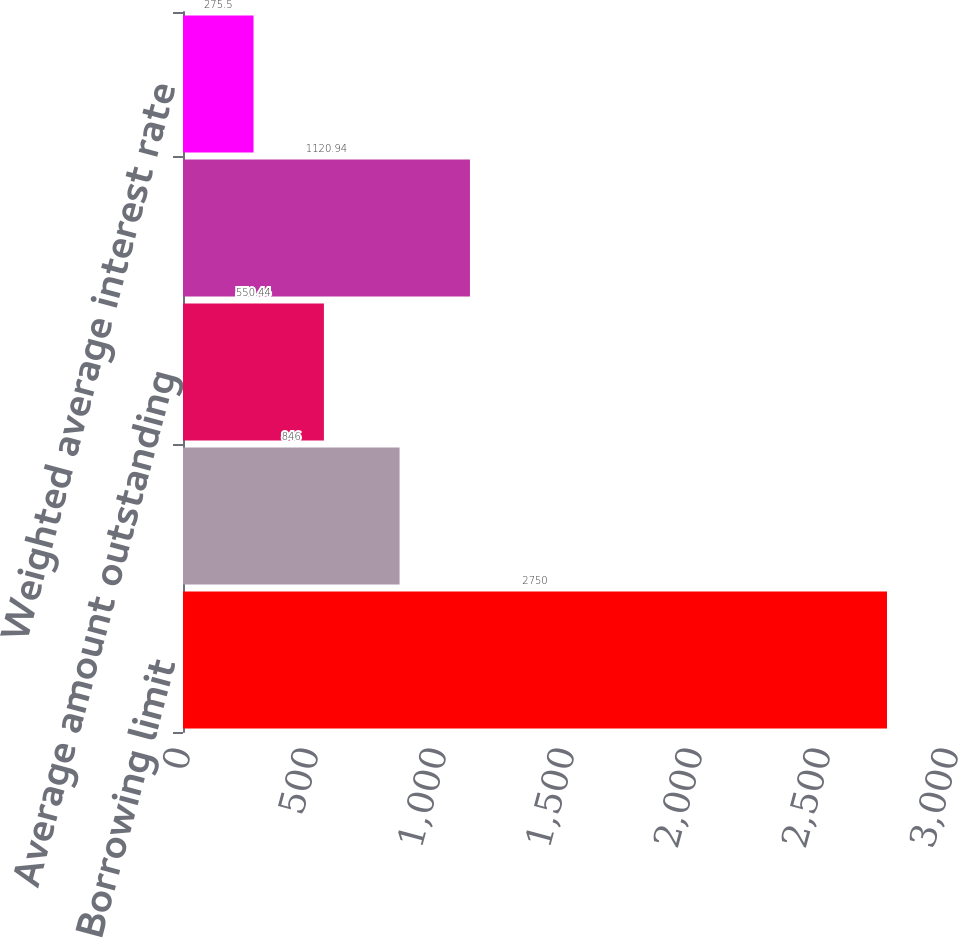<chart> <loc_0><loc_0><loc_500><loc_500><bar_chart><fcel>Borrowing limit<fcel>Amount outstanding at period<fcel>Average amount outstanding<fcel>Maximum amount outstanding<fcel>Weighted average interest rate<nl><fcel>2750<fcel>846<fcel>550.44<fcel>1120.94<fcel>275.5<nl></chart> 